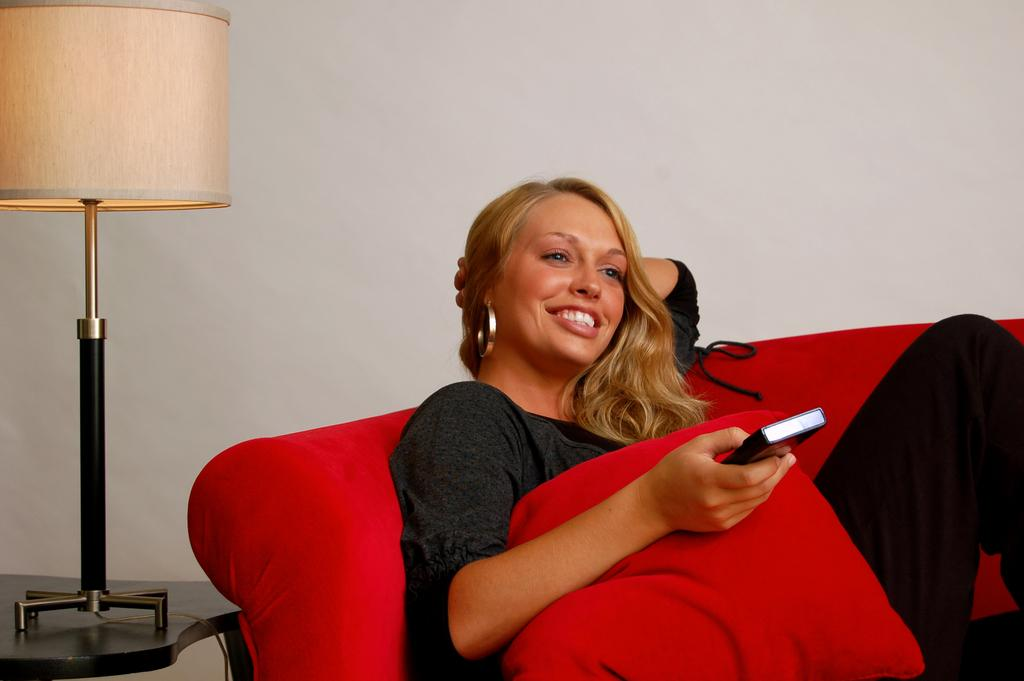Who is the main subject in the image? There is a woman in the image. What is the woman doing in the image? The woman is sitting on a chair. What objects is the woman holding in the image? The woman is holding a remote and a red pillow. What can be seen on the left side of the image? There is a lamp on a table on the left side of the image. What type of wound can be seen on the woman's arm in the image? There is no wound visible on the woman's arm in the image. 